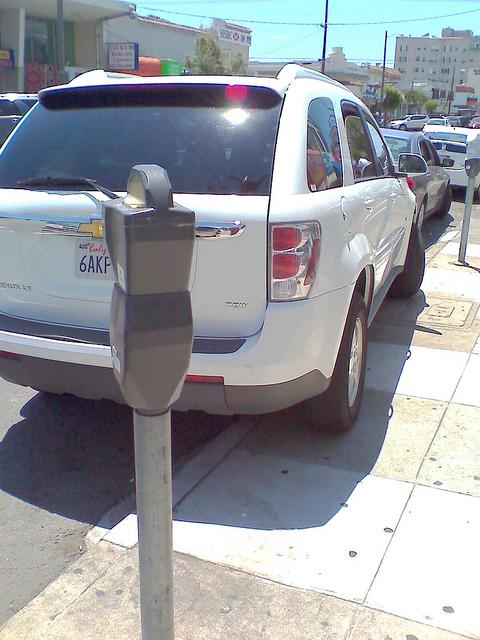Is the car parked illegally?
Concise answer only. Yes. Why would someone park like this?
Keep it brief. In hurry. What auto maker makes the minivan?
Quick response, please. Chevrolet. 